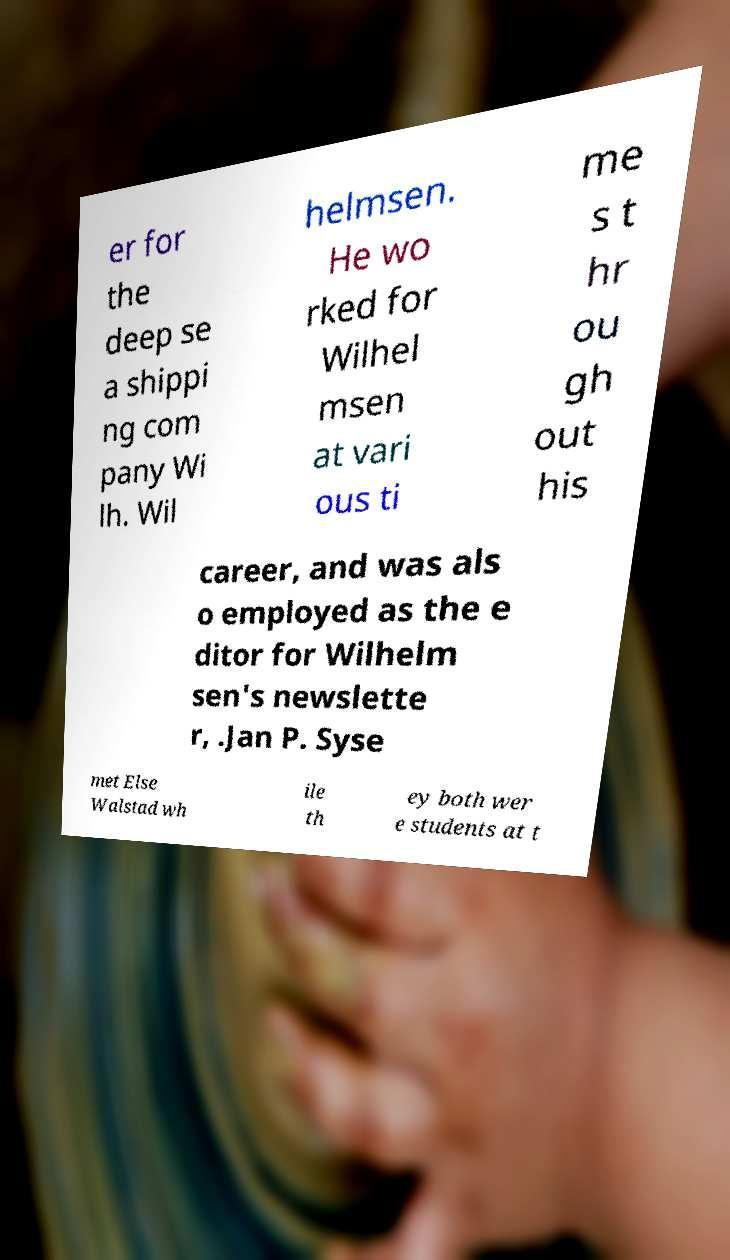For documentation purposes, I need the text within this image transcribed. Could you provide that? er for the deep se a shippi ng com pany Wi lh. Wil helmsen. He wo rked for Wilhel msen at vari ous ti me s t hr ou gh out his career, and was als o employed as the e ditor for Wilhelm sen's newslette r, .Jan P. Syse met Else Walstad wh ile th ey both wer e students at t 